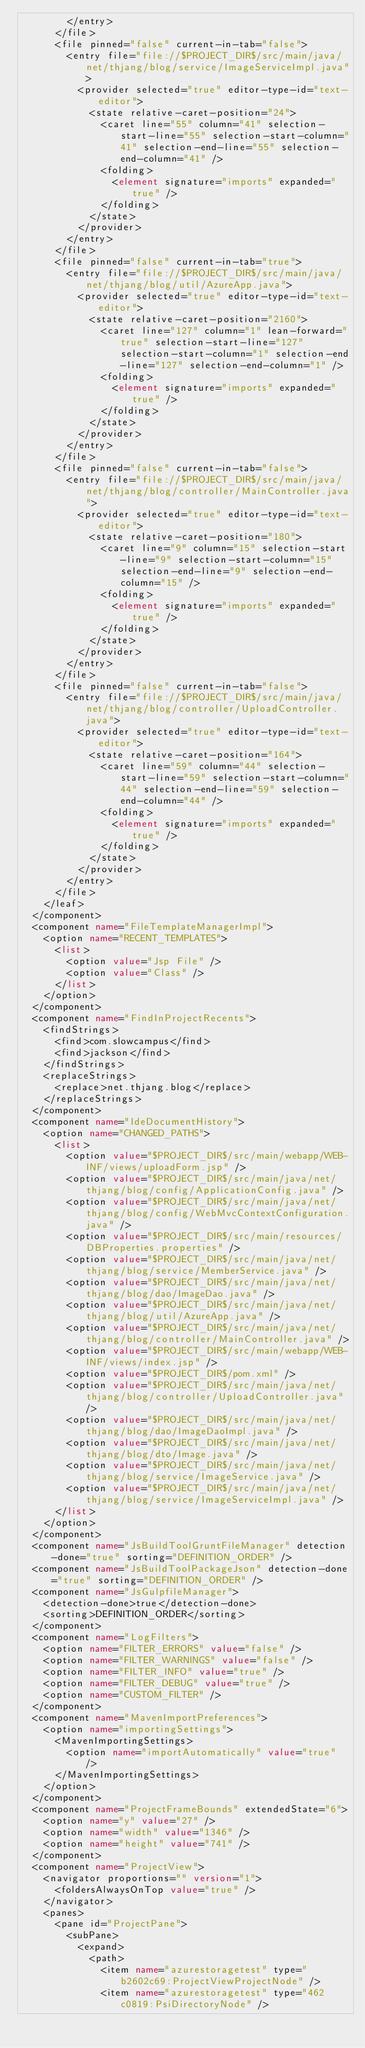Convert code to text. <code><loc_0><loc_0><loc_500><loc_500><_XML_>        </entry>
      </file>
      <file pinned="false" current-in-tab="false">
        <entry file="file://$PROJECT_DIR$/src/main/java/net/thjang/blog/service/ImageServiceImpl.java">
          <provider selected="true" editor-type-id="text-editor">
            <state relative-caret-position="24">
              <caret line="55" column="41" selection-start-line="55" selection-start-column="41" selection-end-line="55" selection-end-column="41" />
              <folding>
                <element signature="imports" expanded="true" />
              </folding>
            </state>
          </provider>
        </entry>
      </file>
      <file pinned="false" current-in-tab="true">
        <entry file="file://$PROJECT_DIR$/src/main/java/net/thjang/blog/util/AzureApp.java">
          <provider selected="true" editor-type-id="text-editor">
            <state relative-caret-position="2160">
              <caret line="127" column="1" lean-forward="true" selection-start-line="127" selection-start-column="1" selection-end-line="127" selection-end-column="1" />
              <folding>
                <element signature="imports" expanded="true" />
              </folding>
            </state>
          </provider>
        </entry>
      </file>
      <file pinned="false" current-in-tab="false">
        <entry file="file://$PROJECT_DIR$/src/main/java/net/thjang/blog/controller/MainController.java">
          <provider selected="true" editor-type-id="text-editor">
            <state relative-caret-position="180">
              <caret line="9" column="15" selection-start-line="9" selection-start-column="15" selection-end-line="9" selection-end-column="15" />
              <folding>
                <element signature="imports" expanded="true" />
              </folding>
            </state>
          </provider>
        </entry>
      </file>
      <file pinned="false" current-in-tab="false">
        <entry file="file://$PROJECT_DIR$/src/main/java/net/thjang/blog/controller/UploadController.java">
          <provider selected="true" editor-type-id="text-editor">
            <state relative-caret-position="164">
              <caret line="59" column="44" selection-start-line="59" selection-start-column="44" selection-end-line="59" selection-end-column="44" />
              <folding>
                <element signature="imports" expanded="true" />
              </folding>
            </state>
          </provider>
        </entry>
      </file>
    </leaf>
  </component>
  <component name="FileTemplateManagerImpl">
    <option name="RECENT_TEMPLATES">
      <list>
        <option value="Jsp File" />
        <option value="Class" />
      </list>
    </option>
  </component>
  <component name="FindInProjectRecents">
    <findStrings>
      <find>com.slowcampus</find>
      <find>jackson</find>
    </findStrings>
    <replaceStrings>
      <replace>net.thjang.blog</replace>
    </replaceStrings>
  </component>
  <component name="IdeDocumentHistory">
    <option name="CHANGED_PATHS">
      <list>
        <option value="$PROJECT_DIR$/src/main/webapp/WEB-INF/views/uploadForm.jsp" />
        <option value="$PROJECT_DIR$/src/main/java/net/thjang/blog/config/ApplicationConfig.java" />
        <option value="$PROJECT_DIR$/src/main/java/net/thjang/blog/config/WebMvcContextConfiguration.java" />
        <option value="$PROJECT_DIR$/src/main/resources/DBProperties.properties" />
        <option value="$PROJECT_DIR$/src/main/java/net/thjang/blog/service/MemberService.java" />
        <option value="$PROJECT_DIR$/src/main/java/net/thjang/blog/dao/ImageDao.java" />
        <option value="$PROJECT_DIR$/src/main/java/net/thjang/blog/util/AzureApp.java" />
        <option value="$PROJECT_DIR$/src/main/java/net/thjang/blog/controller/MainController.java" />
        <option value="$PROJECT_DIR$/src/main/webapp/WEB-INF/views/index.jsp" />
        <option value="$PROJECT_DIR$/pom.xml" />
        <option value="$PROJECT_DIR$/src/main/java/net/thjang/blog/controller/UploadController.java" />
        <option value="$PROJECT_DIR$/src/main/java/net/thjang/blog/dao/ImageDaoImpl.java" />
        <option value="$PROJECT_DIR$/src/main/java/net/thjang/blog/dto/Image.java" />
        <option value="$PROJECT_DIR$/src/main/java/net/thjang/blog/service/ImageService.java" />
        <option value="$PROJECT_DIR$/src/main/java/net/thjang/blog/service/ImageServiceImpl.java" />
      </list>
    </option>
  </component>
  <component name="JsBuildToolGruntFileManager" detection-done="true" sorting="DEFINITION_ORDER" />
  <component name="JsBuildToolPackageJson" detection-done="true" sorting="DEFINITION_ORDER" />
  <component name="JsGulpfileManager">
    <detection-done>true</detection-done>
    <sorting>DEFINITION_ORDER</sorting>
  </component>
  <component name="LogFilters">
    <option name="FILTER_ERRORS" value="false" />
    <option name="FILTER_WARNINGS" value="false" />
    <option name="FILTER_INFO" value="true" />
    <option name="FILTER_DEBUG" value="true" />
    <option name="CUSTOM_FILTER" />
  </component>
  <component name="MavenImportPreferences">
    <option name="importingSettings">
      <MavenImportingSettings>
        <option name="importAutomatically" value="true" />
      </MavenImportingSettings>
    </option>
  </component>
  <component name="ProjectFrameBounds" extendedState="6">
    <option name="y" value="27" />
    <option name="width" value="1346" />
    <option name="height" value="741" />
  </component>
  <component name="ProjectView">
    <navigator proportions="" version="1">
      <foldersAlwaysOnTop value="true" />
    </navigator>
    <panes>
      <pane id="ProjectPane">
        <subPane>
          <expand>
            <path>
              <item name="azurestoragetest" type="b2602c69:ProjectViewProjectNode" />
              <item name="azurestoragetest" type="462c0819:PsiDirectoryNode" /></code> 